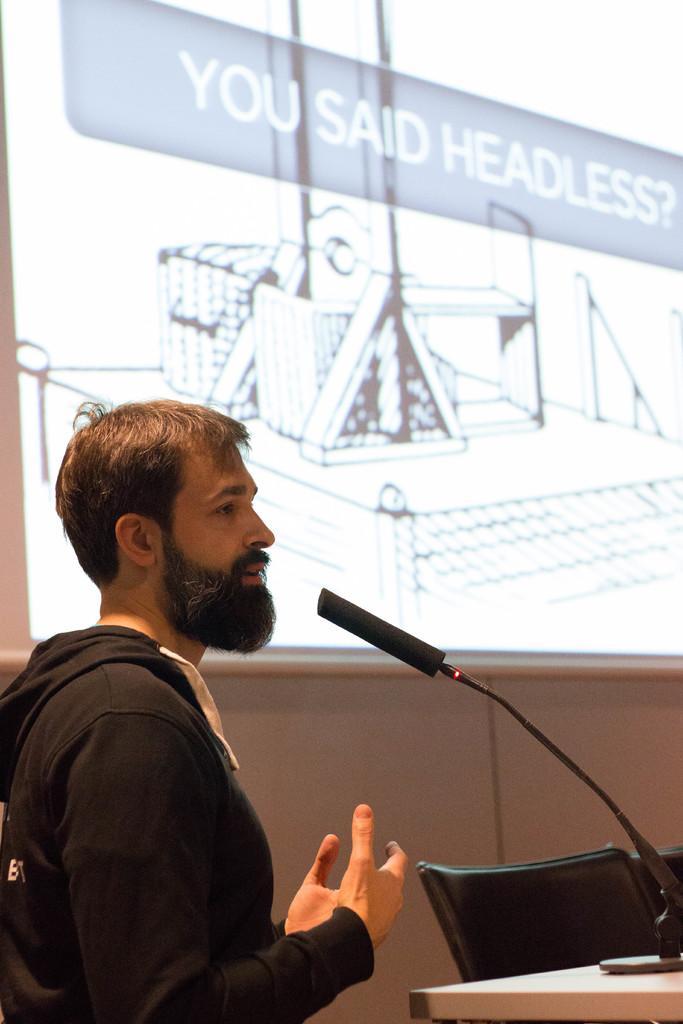Please provide a concise description of this image. In this image we can see a person standing and we can also see a microphone, chairs and projector screen. 